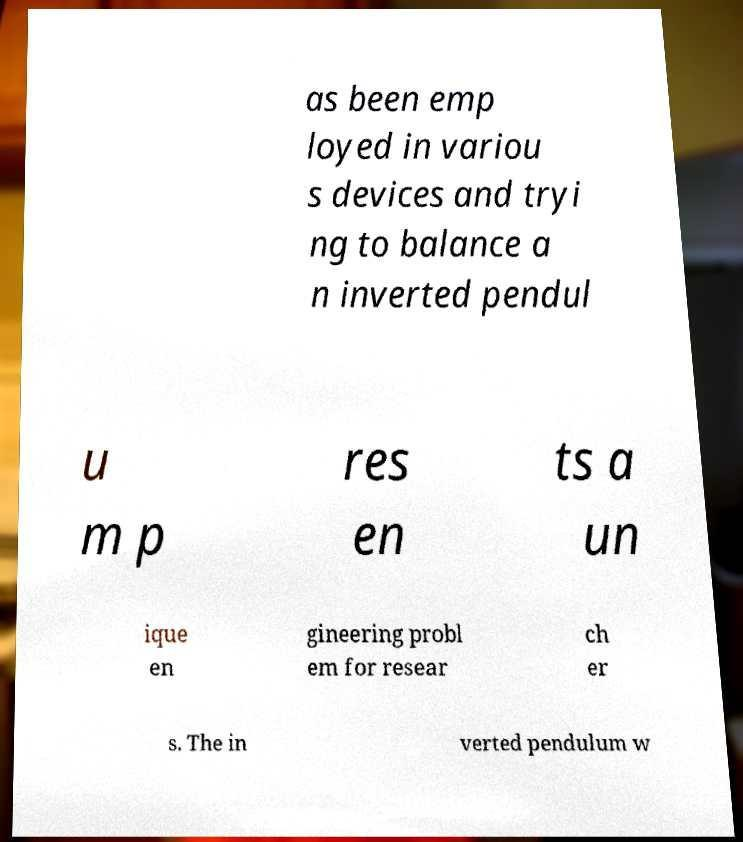What messages or text are displayed in this image? I need them in a readable, typed format. as been emp loyed in variou s devices and tryi ng to balance a n inverted pendul u m p res en ts a un ique en gineering probl em for resear ch er s. The in verted pendulum w 